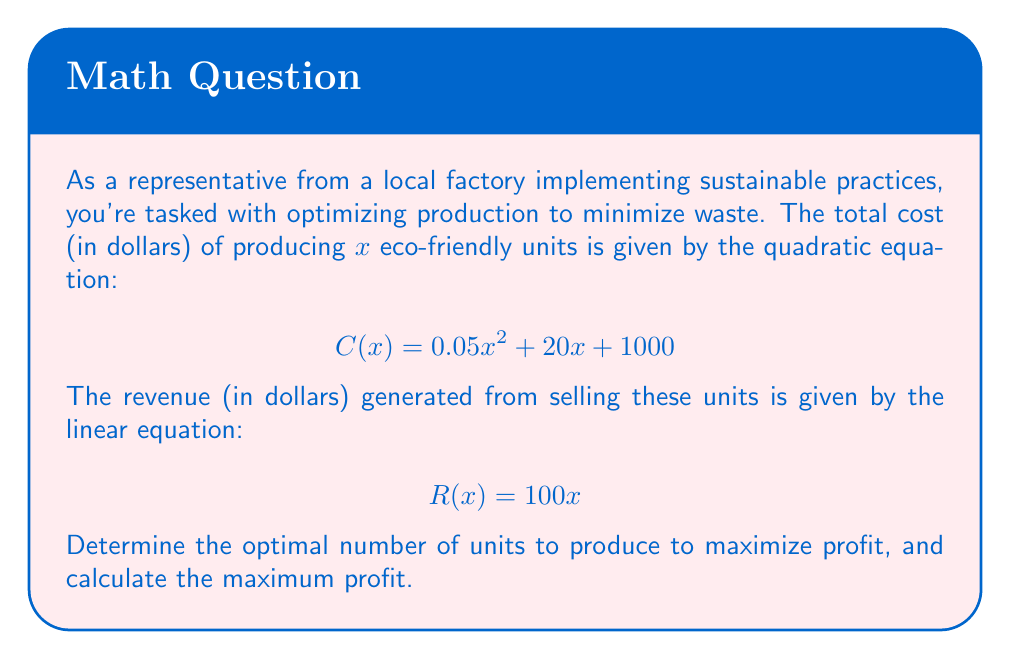Provide a solution to this math problem. To solve this problem, we'll follow these steps:

1) First, let's define the profit function. Profit is revenue minus cost:
   $$ P(x) = R(x) - C(x) $$

2) Substitute the given equations:
   $$ P(x) = 100x - (0.05x^2 + 20x + 1000) $$
   $$ P(x) = 100x - 0.05x^2 - 20x - 1000 $$
   $$ P(x) = -0.05x^2 + 80x - 1000 $$

3) To find the maximum profit, we need to find the vertex of this parabola. We can do this by finding where the derivative equals zero:

   $$ P'(x) = -0.1x + 80 $$
   
   Set $P'(x) = 0$:
   $$ -0.1x + 80 = 0 $$
   $$ -0.1x = -80 $$
   $$ x = 800 $$

4) This x-value represents the number of units that maximizes profit. To find the maximum profit, we substitute this value back into our profit function:

   $$ P(800) = -0.05(800)^2 + 80(800) - 1000 $$
   $$ = -0.05(640000) + 64000 - 1000 $$
   $$ = -32000 + 64000 - 1000 $$
   $$ = 31000 $$

Therefore, the optimal number of units to produce is 800, and the maximum profit is $31,000.
Answer: Optimal production quantity: 800 units
Maximum profit: $31,000 